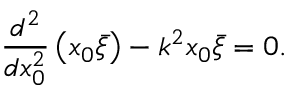Convert formula to latex. <formula><loc_0><loc_0><loc_500><loc_500>\frac { d ^ { 2 } } { d x _ { 0 } ^ { 2 } } \left ( x _ { 0 } \bar { \xi } \right ) - k ^ { 2 } x _ { 0 } \bar { \xi } = 0 .</formula> 